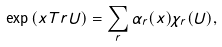<formula> <loc_0><loc_0><loc_500><loc_500>\exp \left ( x T r U \right ) = \sum _ { r } \alpha _ { r } ( x ) \chi _ { r } ( U ) ,</formula> 